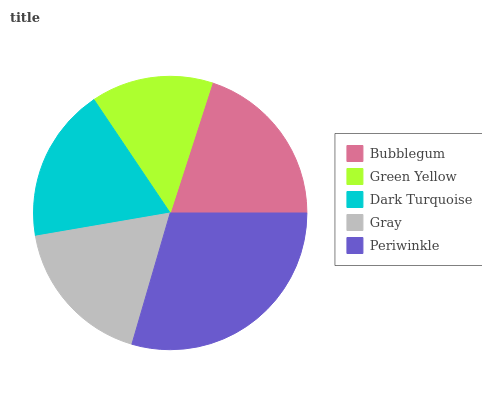Is Green Yellow the minimum?
Answer yes or no. Yes. Is Periwinkle the maximum?
Answer yes or no. Yes. Is Dark Turquoise the minimum?
Answer yes or no. No. Is Dark Turquoise the maximum?
Answer yes or no. No. Is Dark Turquoise greater than Green Yellow?
Answer yes or no. Yes. Is Green Yellow less than Dark Turquoise?
Answer yes or no. Yes. Is Green Yellow greater than Dark Turquoise?
Answer yes or no. No. Is Dark Turquoise less than Green Yellow?
Answer yes or no. No. Is Dark Turquoise the high median?
Answer yes or no. Yes. Is Dark Turquoise the low median?
Answer yes or no. Yes. Is Bubblegum the high median?
Answer yes or no. No. Is Gray the low median?
Answer yes or no. No. 